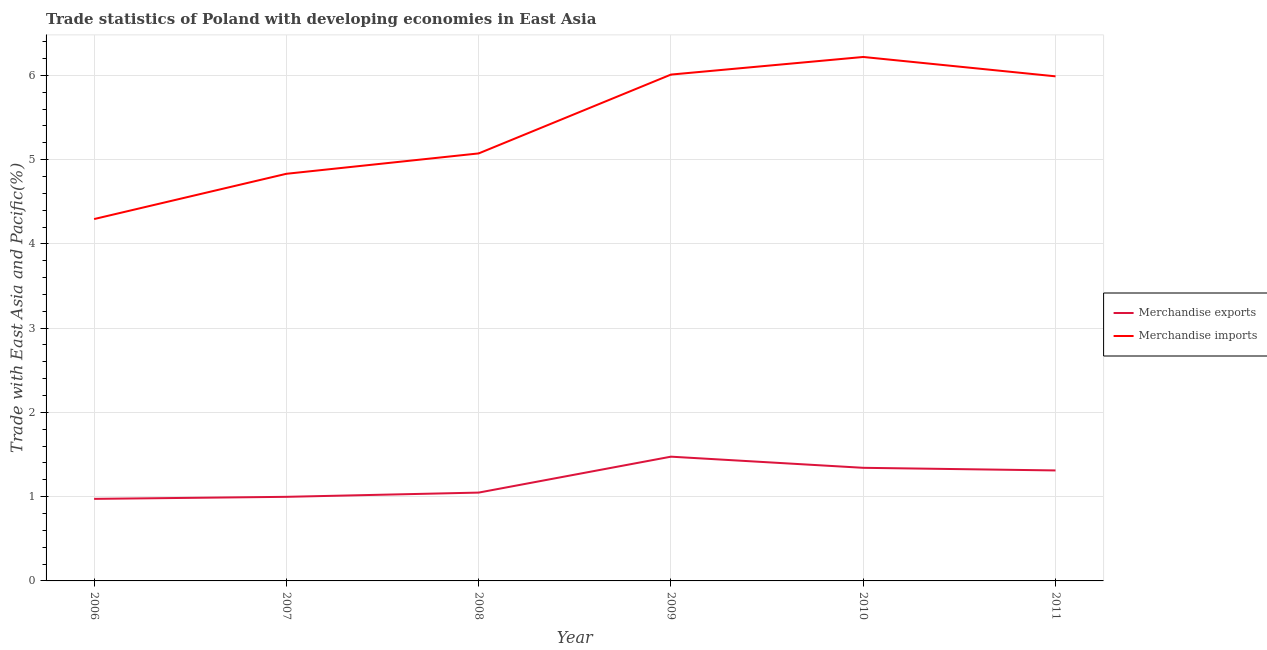What is the merchandise imports in 2006?
Offer a very short reply. 4.29. Across all years, what is the maximum merchandise exports?
Ensure brevity in your answer.  1.47. Across all years, what is the minimum merchandise imports?
Offer a terse response. 4.29. In which year was the merchandise imports maximum?
Provide a short and direct response. 2010. In which year was the merchandise exports minimum?
Give a very brief answer. 2006. What is the total merchandise imports in the graph?
Provide a succinct answer. 32.41. What is the difference between the merchandise imports in 2008 and that in 2011?
Give a very brief answer. -0.91. What is the difference between the merchandise imports in 2006 and the merchandise exports in 2008?
Offer a very short reply. 3.25. What is the average merchandise exports per year?
Your response must be concise. 1.19. In the year 2007, what is the difference between the merchandise exports and merchandise imports?
Provide a short and direct response. -3.83. In how many years, is the merchandise imports greater than 4.2 %?
Offer a very short reply. 6. What is the ratio of the merchandise imports in 2006 to that in 2008?
Your response must be concise. 0.85. Is the difference between the merchandise imports in 2008 and 2010 greater than the difference between the merchandise exports in 2008 and 2010?
Make the answer very short. No. What is the difference between the highest and the second highest merchandise exports?
Your answer should be compact. 0.13. What is the difference between the highest and the lowest merchandise imports?
Provide a short and direct response. 1.92. Is the sum of the merchandise exports in 2008 and 2011 greater than the maximum merchandise imports across all years?
Offer a very short reply. No. Does the merchandise imports monotonically increase over the years?
Ensure brevity in your answer.  No. Does the graph contain grids?
Offer a very short reply. Yes. Where does the legend appear in the graph?
Provide a short and direct response. Center right. How many legend labels are there?
Offer a very short reply. 2. What is the title of the graph?
Provide a short and direct response. Trade statistics of Poland with developing economies in East Asia. What is the label or title of the X-axis?
Keep it short and to the point. Year. What is the label or title of the Y-axis?
Your response must be concise. Trade with East Asia and Pacific(%). What is the Trade with East Asia and Pacific(%) in Merchandise exports in 2006?
Keep it short and to the point. 0.97. What is the Trade with East Asia and Pacific(%) of Merchandise imports in 2006?
Make the answer very short. 4.29. What is the Trade with East Asia and Pacific(%) of Merchandise exports in 2007?
Offer a very short reply. 1. What is the Trade with East Asia and Pacific(%) in Merchandise imports in 2007?
Give a very brief answer. 4.83. What is the Trade with East Asia and Pacific(%) in Merchandise exports in 2008?
Make the answer very short. 1.05. What is the Trade with East Asia and Pacific(%) in Merchandise imports in 2008?
Your answer should be very brief. 5.07. What is the Trade with East Asia and Pacific(%) in Merchandise exports in 2009?
Your response must be concise. 1.47. What is the Trade with East Asia and Pacific(%) in Merchandise imports in 2009?
Provide a succinct answer. 6.01. What is the Trade with East Asia and Pacific(%) in Merchandise exports in 2010?
Your answer should be very brief. 1.34. What is the Trade with East Asia and Pacific(%) in Merchandise imports in 2010?
Keep it short and to the point. 6.22. What is the Trade with East Asia and Pacific(%) of Merchandise exports in 2011?
Make the answer very short. 1.31. What is the Trade with East Asia and Pacific(%) in Merchandise imports in 2011?
Make the answer very short. 5.99. Across all years, what is the maximum Trade with East Asia and Pacific(%) in Merchandise exports?
Offer a terse response. 1.47. Across all years, what is the maximum Trade with East Asia and Pacific(%) in Merchandise imports?
Make the answer very short. 6.22. Across all years, what is the minimum Trade with East Asia and Pacific(%) of Merchandise exports?
Your answer should be very brief. 0.97. Across all years, what is the minimum Trade with East Asia and Pacific(%) in Merchandise imports?
Ensure brevity in your answer.  4.29. What is the total Trade with East Asia and Pacific(%) of Merchandise exports in the graph?
Your response must be concise. 7.15. What is the total Trade with East Asia and Pacific(%) in Merchandise imports in the graph?
Provide a short and direct response. 32.41. What is the difference between the Trade with East Asia and Pacific(%) of Merchandise exports in 2006 and that in 2007?
Your answer should be compact. -0.02. What is the difference between the Trade with East Asia and Pacific(%) of Merchandise imports in 2006 and that in 2007?
Your response must be concise. -0.54. What is the difference between the Trade with East Asia and Pacific(%) of Merchandise exports in 2006 and that in 2008?
Provide a succinct answer. -0.07. What is the difference between the Trade with East Asia and Pacific(%) in Merchandise imports in 2006 and that in 2008?
Make the answer very short. -0.78. What is the difference between the Trade with East Asia and Pacific(%) of Merchandise exports in 2006 and that in 2009?
Keep it short and to the point. -0.5. What is the difference between the Trade with East Asia and Pacific(%) of Merchandise imports in 2006 and that in 2009?
Your answer should be compact. -1.71. What is the difference between the Trade with East Asia and Pacific(%) in Merchandise exports in 2006 and that in 2010?
Make the answer very short. -0.37. What is the difference between the Trade with East Asia and Pacific(%) in Merchandise imports in 2006 and that in 2010?
Offer a very short reply. -1.92. What is the difference between the Trade with East Asia and Pacific(%) in Merchandise exports in 2006 and that in 2011?
Give a very brief answer. -0.34. What is the difference between the Trade with East Asia and Pacific(%) in Merchandise imports in 2006 and that in 2011?
Provide a succinct answer. -1.69. What is the difference between the Trade with East Asia and Pacific(%) of Merchandise exports in 2007 and that in 2008?
Give a very brief answer. -0.05. What is the difference between the Trade with East Asia and Pacific(%) in Merchandise imports in 2007 and that in 2008?
Your answer should be compact. -0.24. What is the difference between the Trade with East Asia and Pacific(%) in Merchandise exports in 2007 and that in 2009?
Give a very brief answer. -0.48. What is the difference between the Trade with East Asia and Pacific(%) in Merchandise imports in 2007 and that in 2009?
Offer a terse response. -1.18. What is the difference between the Trade with East Asia and Pacific(%) in Merchandise exports in 2007 and that in 2010?
Provide a succinct answer. -0.34. What is the difference between the Trade with East Asia and Pacific(%) of Merchandise imports in 2007 and that in 2010?
Your answer should be very brief. -1.39. What is the difference between the Trade with East Asia and Pacific(%) of Merchandise exports in 2007 and that in 2011?
Make the answer very short. -0.31. What is the difference between the Trade with East Asia and Pacific(%) in Merchandise imports in 2007 and that in 2011?
Provide a succinct answer. -1.16. What is the difference between the Trade with East Asia and Pacific(%) of Merchandise exports in 2008 and that in 2009?
Your response must be concise. -0.43. What is the difference between the Trade with East Asia and Pacific(%) in Merchandise imports in 2008 and that in 2009?
Your response must be concise. -0.94. What is the difference between the Trade with East Asia and Pacific(%) of Merchandise exports in 2008 and that in 2010?
Ensure brevity in your answer.  -0.29. What is the difference between the Trade with East Asia and Pacific(%) of Merchandise imports in 2008 and that in 2010?
Provide a succinct answer. -1.14. What is the difference between the Trade with East Asia and Pacific(%) in Merchandise exports in 2008 and that in 2011?
Make the answer very short. -0.26. What is the difference between the Trade with East Asia and Pacific(%) of Merchandise imports in 2008 and that in 2011?
Your response must be concise. -0.91. What is the difference between the Trade with East Asia and Pacific(%) in Merchandise exports in 2009 and that in 2010?
Your answer should be very brief. 0.13. What is the difference between the Trade with East Asia and Pacific(%) of Merchandise imports in 2009 and that in 2010?
Give a very brief answer. -0.21. What is the difference between the Trade with East Asia and Pacific(%) in Merchandise exports in 2009 and that in 2011?
Your answer should be compact. 0.16. What is the difference between the Trade with East Asia and Pacific(%) in Merchandise imports in 2009 and that in 2011?
Your answer should be compact. 0.02. What is the difference between the Trade with East Asia and Pacific(%) of Merchandise exports in 2010 and that in 2011?
Give a very brief answer. 0.03. What is the difference between the Trade with East Asia and Pacific(%) of Merchandise imports in 2010 and that in 2011?
Provide a succinct answer. 0.23. What is the difference between the Trade with East Asia and Pacific(%) in Merchandise exports in 2006 and the Trade with East Asia and Pacific(%) in Merchandise imports in 2007?
Offer a very short reply. -3.86. What is the difference between the Trade with East Asia and Pacific(%) of Merchandise exports in 2006 and the Trade with East Asia and Pacific(%) of Merchandise imports in 2008?
Offer a terse response. -4.1. What is the difference between the Trade with East Asia and Pacific(%) in Merchandise exports in 2006 and the Trade with East Asia and Pacific(%) in Merchandise imports in 2009?
Make the answer very short. -5.04. What is the difference between the Trade with East Asia and Pacific(%) in Merchandise exports in 2006 and the Trade with East Asia and Pacific(%) in Merchandise imports in 2010?
Provide a succinct answer. -5.24. What is the difference between the Trade with East Asia and Pacific(%) of Merchandise exports in 2006 and the Trade with East Asia and Pacific(%) of Merchandise imports in 2011?
Your response must be concise. -5.01. What is the difference between the Trade with East Asia and Pacific(%) in Merchandise exports in 2007 and the Trade with East Asia and Pacific(%) in Merchandise imports in 2008?
Offer a very short reply. -4.08. What is the difference between the Trade with East Asia and Pacific(%) in Merchandise exports in 2007 and the Trade with East Asia and Pacific(%) in Merchandise imports in 2009?
Your answer should be compact. -5.01. What is the difference between the Trade with East Asia and Pacific(%) in Merchandise exports in 2007 and the Trade with East Asia and Pacific(%) in Merchandise imports in 2010?
Offer a very short reply. -5.22. What is the difference between the Trade with East Asia and Pacific(%) in Merchandise exports in 2007 and the Trade with East Asia and Pacific(%) in Merchandise imports in 2011?
Offer a terse response. -4.99. What is the difference between the Trade with East Asia and Pacific(%) of Merchandise exports in 2008 and the Trade with East Asia and Pacific(%) of Merchandise imports in 2009?
Keep it short and to the point. -4.96. What is the difference between the Trade with East Asia and Pacific(%) in Merchandise exports in 2008 and the Trade with East Asia and Pacific(%) in Merchandise imports in 2010?
Give a very brief answer. -5.17. What is the difference between the Trade with East Asia and Pacific(%) of Merchandise exports in 2008 and the Trade with East Asia and Pacific(%) of Merchandise imports in 2011?
Your response must be concise. -4.94. What is the difference between the Trade with East Asia and Pacific(%) in Merchandise exports in 2009 and the Trade with East Asia and Pacific(%) in Merchandise imports in 2010?
Offer a very short reply. -4.74. What is the difference between the Trade with East Asia and Pacific(%) in Merchandise exports in 2009 and the Trade with East Asia and Pacific(%) in Merchandise imports in 2011?
Make the answer very short. -4.51. What is the difference between the Trade with East Asia and Pacific(%) of Merchandise exports in 2010 and the Trade with East Asia and Pacific(%) of Merchandise imports in 2011?
Offer a very short reply. -4.65. What is the average Trade with East Asia and Pacific(%) in Merchandise exports per year?
Provide a short and direct response. 1.19. What is the average Trade with East Asia and Pacific(%) of Merchandise imports per year?
Make the answer very short. 5.4. In the year 2006, what is the difference between the Trade with East Asia and Pacific(%) of Merchandise exports and Trade with East Asia and Pacific(%) of Merchandise imports?
Ensure brevity in your answer.  -3.32. In the year 2007, what is the difference between the Trade with East Asia and Pacific(%) in Merchandise exports and Trade with East Asia and Pacific(%) in Merchandise imports?
Ensure brevity in your answer.  -3.83. In the year 2008, what is the difference between the Trade with East Asia and Pacific(%) in Merchandise exports and Trade with East Asia and Pacific(%) in Merchandise imports?
Your answer should be compact. -4.03. In the year 2009, what is the difference between the Trade with East Asia and Pacific(%) in Merchandise exports and Trade with East Asia and Pacific(%) in Merchandise imports?
Your response must be concise. -4.53. In the year 2010, what is the difference between the Trade with East Asia and Pacific(%) of Merchandise exports and Trade with East Asia and Pacific(%) of Merchandise imports?
Your response must be concise. -4.88. In the year 2011, what is the difference between the Trade with East Asia and Pacific(%) of Merchandise exports and Trade with East Asia and Pacific(%) of Merchandise imports?
Ensure brevity in your answer.  -4.68. What is the ratio of the Trade with East Asia and Pacific(%) in Merchandise exports in 2006 to that in 2007?
Provide a short and direct response. 0.98. What is the ratio of the Trade with East Asia and Pacific(%) in Merchandise imports in 2006 to that in 2007?
Offer a very short reply. 0.89. What is the ratio of the Trade with East Asia and Pacific(%) of Merchandise exports in 2006 to that in 2008?
Ensure brevity in your answer.  0.93. What is the ratio of the Trade with East Asia and Pacific(%) in Merchandise imports in 2006 to that in 2008?
Make the answer very short. 0.85. What is the ratio of the Trade with East Asia and Pacific(%) of Merchandise exports in 2006 to that in 2009?
Ensure brevity in your answer.  0.66. What is the ratio of the Trade with East Asia and Pacific(%) in Merchandise imports in 2006 to that in 2009?
Your answer should be very brief. 0.71. What is the ratio of the Trade with East Asia and Pacific(%) of Merchandise exports in 2006 to that in 2010?
Your response must be concise. 0.73. What is the ratio of the Trade with East Asia and Pacific(%) in Merchandise imports in 2006 to that in 2010?
Offer a terse response. 0.69. What is the ratio of the Trade with East Asia and Pacific(%) in Merchandise exports in 2006 to that in 2011?
Keep it short and to the point. 0.74. What is the ratio of the Trade with East Asia and Pacific(%) in Merchandise imports in 2006 to that in 2011?
Your answer should be compact. 0.72. What is the ratio of the Trade with East Asia and Pacific(%) in Merchandise exports in 2007 to that in 2008?
Provide a short and direct response. 0.95. What is the ratio of the Trade with East Asia and Pacific(%) in Merchandise imports in 2007 to that in 2008?
Provide a short and direct response. 0.95. What is the ratio of the Trade with East Asia and Pacific(%) in Merchandise exports in 2007 to that in 2009?
Give a very brief answer. 0.68. What is the ratio of the Trade with East Asia and Pacific(%) in Merchandise imports in 2007 to that in 2009?
Offer a terse response. 0.8. What is the ratio of the Trade with East Asia and Pacific(%) of Merchandise exports in 2007 to that in 2010?
Give a very brief answer. 0.74. What is the ratio of the Trade with East Asia and Pacific(%) in Merchandise imports in 2007 to that in 2010?
Provide a succinct answer. 0.78. What is the ratio of the Trade with East Asia and Pacific(%) of Merchandise exports in 2007 to that in 2011?
Offer a terse response. 0.76. What is the ratio of the Trade with East Asia and Pacific(%) in Merchandise imports in 2007 to that in 2011?
Give a very brief answer. 0.81. What is the ratio of the Trade with East Asia and Pacific(%) of Merchandise exports in 2008 to that in 2009?
Keep it short and to the point. 0.71. What is the ratio of the Trade with East Asia and Pacific(%) of Merchandise imports in 2008 to that in 2009?
Your response must be concise. 0.84. What is the ratio of the Trade with East Asia and Pacific(%) of Merchandise exports in 2008 to that in 2010?
Make the answer very short. 0.78. What is the ratio of the Trade with East Asia and Pacific(%) in Merchandise imports in 2008 to that in 2010?
Provide a succinct answer. 0.82. What is the ratio of the Trade with East Asia and Pacific(%) in Merchandise exports in 2008 to that in 2011?
Your answer should be very brief. 0.8. What is the ratio of the Trade with East Asia and Pacific(%) in Merchandise imports in 2008 to that in 2011?
Keep it short and to the point. 0.85. What is the ratio of the Trade with East Asia and Pacific(%) of Merchandise exports in 2009 to that in 2010?
Provide a succinct answer. 1.1. What is the ratio of the Trade with East Asia and Pacific(%) of Merchandise imports in 2009 to that in 2010?
Make the answer very short. 0.97. What is the ratio of the Trade with East Asia and Pacific(%) of Merchandise exports in 2009 to that in 2011?
Make the answer very short. 1.12. What is the ratio of the Trade with East Asia and Pacific(%) in Merchandise imports in 2009 to that in 2011?
Keep it short and to the point. 1. What is the ratio of the Trade with East Asia and Pacific(%) of Merchandise exports in 2010 to that in 2011?
Your response must be concise. 1.02. What is the ratio of the Trade with East Asia and Pacific(%) in Merchandise imports in 2010 to that in 2011?
Provide a succinct answer. 1.04. What is the difference between the highest and the second highest Trade with East Asia and Pacific(%) in Merchandise exports?
Make the answer very short. 0.13. What is the difference between the highest and the second highest Trade with East Asia and Pacific(%) of Merchandise imports?
Your response must be concise. 0.21. What is the difference between the highest and the lowest Trade with East Asia and Pacific(%) of Merchandise exports?
Provide a succinct answer. 0.5. What is the difference between the highest and the lowest Trade with East Asia and Pacific(%) of Merchandise imports?
Provide a short and direct response. 1.92. 